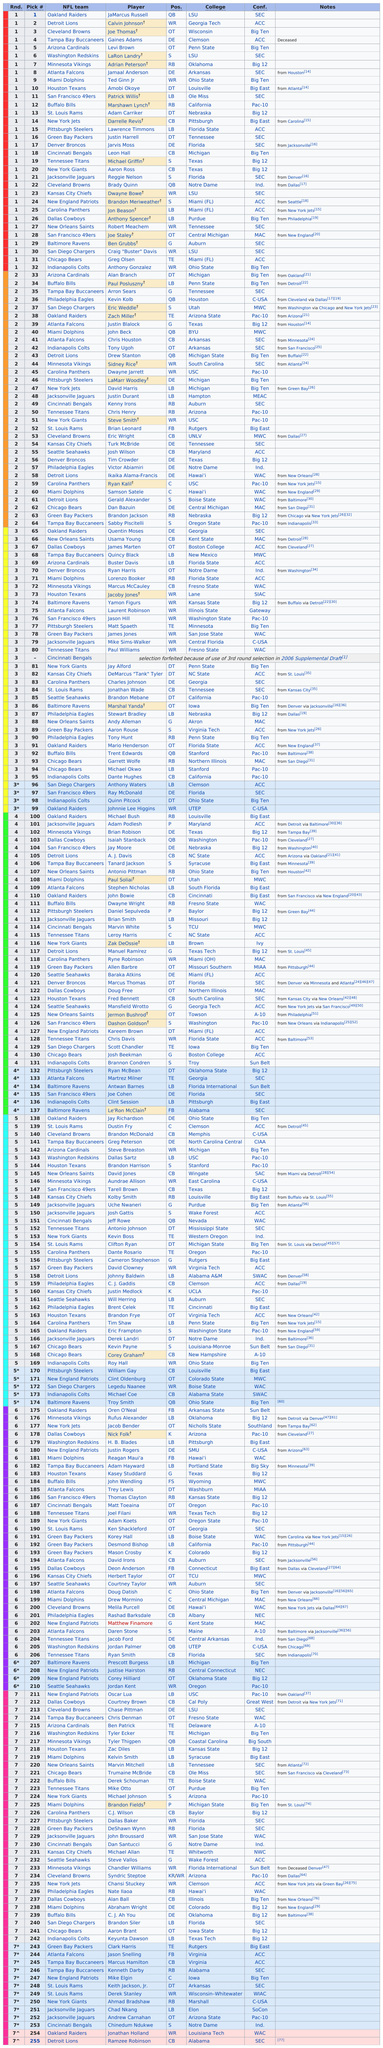Indicate a few pertinent items in this graphic. Joe Thomas was one of the individuals selected in the top 5, and the other individual was Levi Brown. Calvin Johnson, who was selected after Jamarcus Russell, is a highly accomplished and celebrated football player. There are 11 players who are designated as quarterbacks. There were a total of 11 drafted players who were quarterbacks. It is a known fact that the first round draft pick, Calvin Johnson, attended Georgia Tech. 